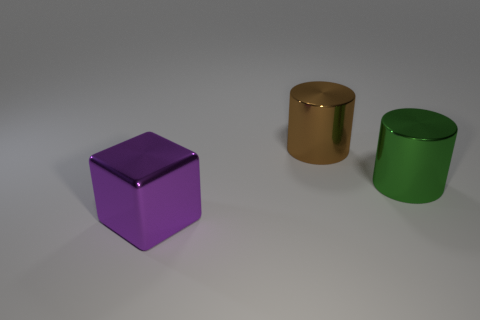There is a thing behind the green cylinder; is its color the same as the large cube?
Provide a short and direct response. No. Are there fewer big purple shiny blocks to the left of the green shiny thing than large purple shiny things?
Your answer should be compact. No. What color is the cube that is made of the same material as the brown object?
Keep it short and to the point. Purple. How big is the purple metal object on the left side of the green cylinder?
Make the answer very short. Large. Does the big brown object have the same material as the big purple object?
Provide a short and direct response. Yes. There is a large metallic cylinder in front of the large metal cylinder that is behind the green shiny cylinder; are there any purple metal cubes that are right of it?
Offer a very short reply. No. What color is the cube?
Your response must be concise. Purple. The other cylinder that is the same size as the brown cylinder is what color?
Offer a terse response. Green. There is a metallic object that is to the left of the brown metal thing; is it the same shape as the large brown metallic object?
Your response must be concise. No. What color is the metallic thing that is to the left of the big cylinder to the left of the large cylinder to the right of the brown shiny object?
Provide a short and direct response. Purple. 